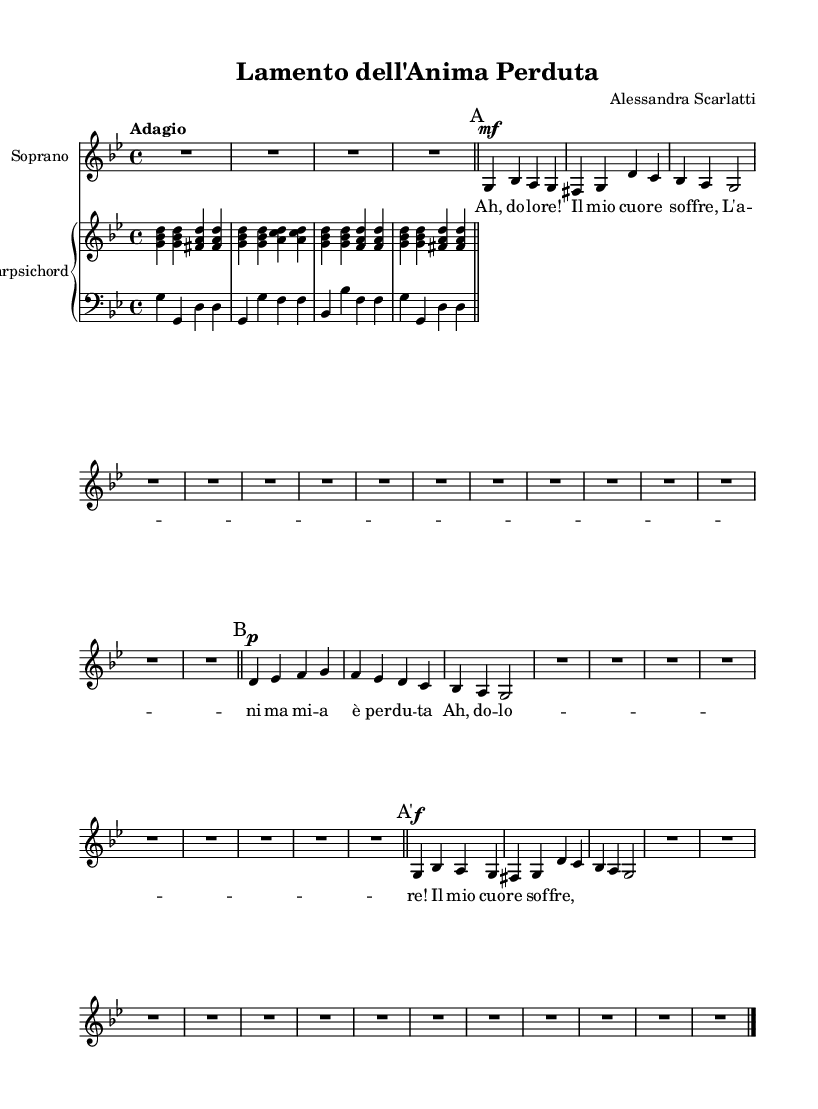What is the key signature of this music? The key signature is G minor, which contains two flats (B♭ and E♭). This can be inferred from the initial indication at the beginning of the score.
Answer: G minor What is the time signature of the piece? The time signature is 4/4, as indicated after the key signature. This means there are four beats per measure, and the quarter note receives one beat.
Answer: 4/4 What is the tempo marking of the piece? The tempo marking is "Adagio," which indicates a slow tempo. This is found at the beginning of the score near the global settings.
Answer: Adagio How many measures are there in section A? Section A consists of three measures. By counting the distinct sections delineated by the bar lines, we can identify the measures.
Answer: 3 Which instrument plays the accompaniment? The accompaniment is played by the Harpsichord, indicated by the label under the staff for the piano, which represents the harpsichord in Baroque music.
Answer: Harpsichord What dynamic marking is used in measure 1 for the soprano part? The dynamic marking is mezzo-forte (mf), which instructs the singer to perform moderately loud. It is indicated at the beginning of the soprano line.
Answer: mezzo-forte What is the vocal dynamic marking in section B? The vocal dynamic marking in section B is piano (p), which instructs the singer to perform softly. This marking is found at the beginning of section B in the soprano line.
Answer: piano 